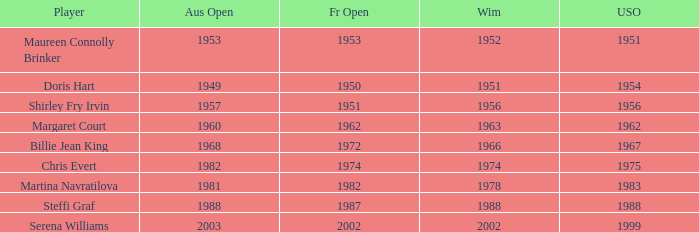What year did Martina Navratilova win Wimbledon? 1978.0. 